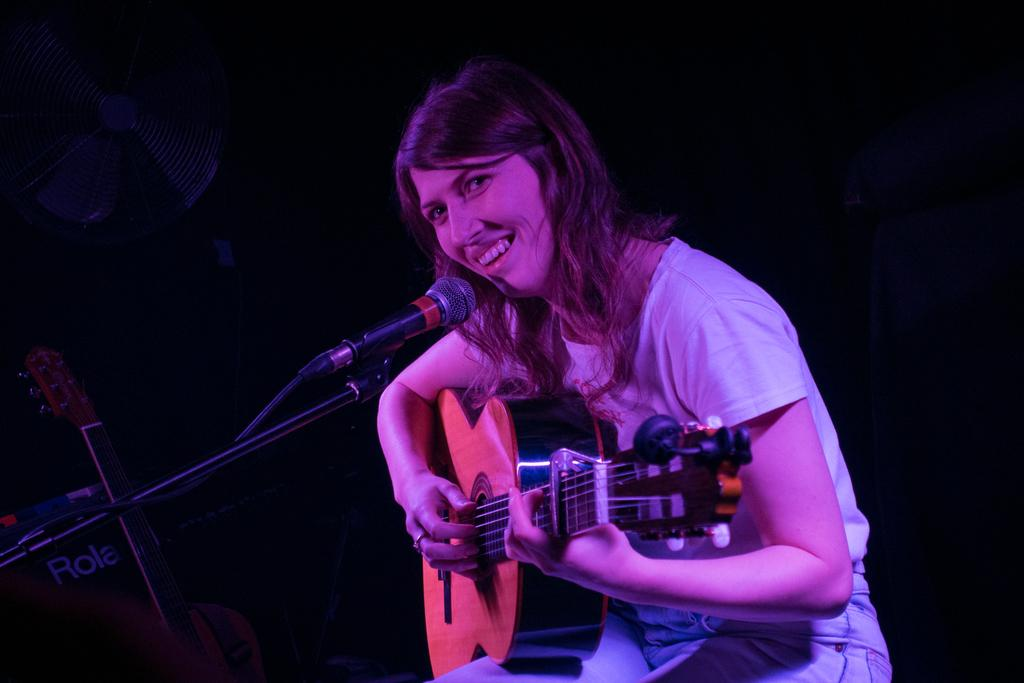Who is the main subject in the image? There is a woman in the image. What is the woman holding in the image? The woman is holding a guitar. What is the woman doing with the guitar? The woman is playing the guitar. What is the woman doing while playing the guitar? The woman is singing on a microphone. What can be observed about the background of the image? There is a dark background in the image. Are there any other musical instruments visible in the image? Yes, there is another guitar in the background. How much payment is the woman receiving for her performance in the image? There is no indication of payment in the image; it only shows the woman playing the guitar and singing on a microphone. 